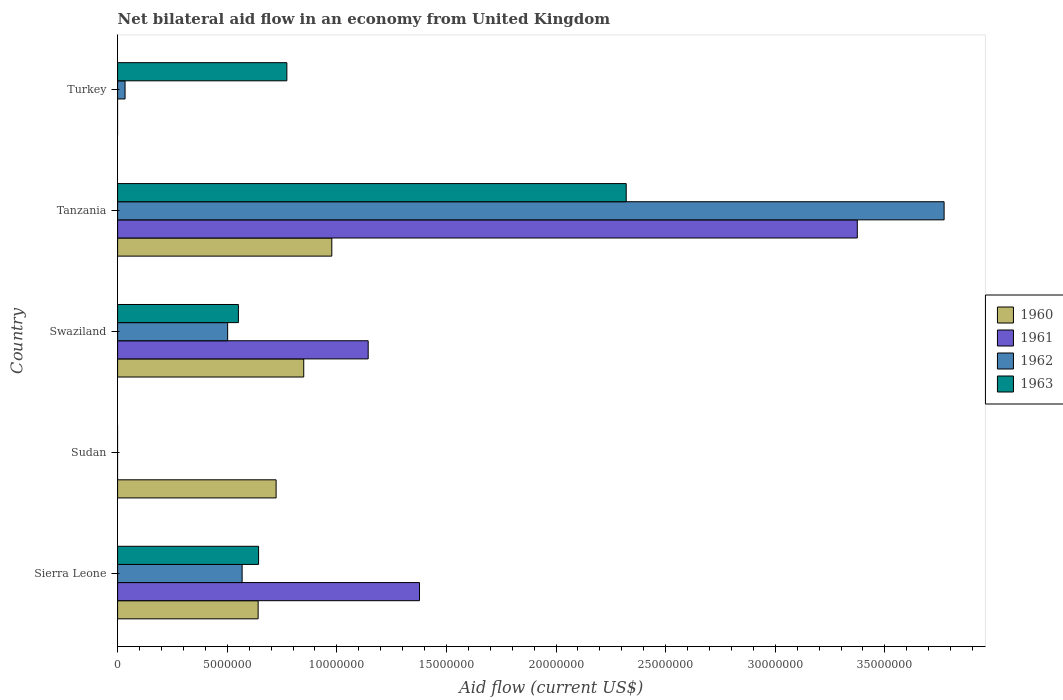Are the number of bars on each tick of the Y-axis equal?
Keep it short and to the point. No. How many bars are there on the 4th tick from the top?
Provide a short and direct response. 1. What is the label of the 4th group of bars from the top?
Provide a succinct answer. Sudan. In how many cases, is the number of bars for a given country not equal to the number of legend labels?
Your response must be concise. 2. What is the net bilateral aid flow in 1962 in Sierra Leone?
Your answer should be very brief. 5.68e+06. Across all countries, what is the maximum net bilateral aid flow in 1962?
Your response must be concise. 3.77e+07. In which country was the net bilateral aid flow in 1960 maximum?
Your answer should be compact. Tanzania. What is the total net bilateral aid flow in 1963 in the graph?
Ensure brevity in your answer.  4.29e+07. What is the difference between the net bilateral aid flow in 1963 in Swaziland and that in Turkey?
Keep it short and to the point. -2.21e+06. What is the difference between the net bilateral aid flow in 1962 in Tanzania and the net bilateral aid flow in 1961 in Swaziland?
Your answer should be very brief. 2.63e+07. What is the average net bilateral aid flow in 1960 per country?
Your answer should be compact. 6.38e+06. What is the difference between the net bilateral aid flow in 1962 and net bilateral aid flow in 1963 in Tanzania?
Your answer should be compact. 1.45e+07. In how many countries, is the net bilateral aid flow in 1962 greater than 9000000 US$?
Your answer should be very brief. 1. What is the ratio of the net bilateral aid flow in 1963 in Sierra Leone to that in Swaziland?
Keep it short and to the point. 1.17. Is the net bilateral aid flow in 1963 in Swaziland less than that in Tanzania?
Provide a succinct answer. Yes. Is the difference between the net bilateral aid flow in 1962 in Swaziland and Tanzania greater than the difference between the net bilateral aid flow in 1963 in Swaziland and Tanzania?
Provide a short and direct response. No. What is the difference between the highest and the second highest net bilateral aid flow in 1960?
Your answer should be compact. 1.28e+06. What is the difference between the highest and the lowest net bilateral aid flow in 1962?
Your response must be concise. 3.77e+07. In how many countries, is the net bilateral aid flow in 1960 greater than the average net bilateral aid flow in 1960 taken over all countries?
Offer a terse response. 4. Is the sum of the net bilateral aid flow in 1963 in Swaziland and Turkey greater than the maximum net bilateral aid flow in 1960 across all countries?
Your answer should be very brief. Yes. Is it the case that in every country, the sum of the net bilateral aid flow in 1960 and net bilateral aid flow in 1962 is greater than the sum of net bilateral aid flow in 1961 and net bilateral aid flow in 1963?
Your answer should be very brief. No. How many countries are there in the graph?
Your answer should be compact. 5. Where does the legend appear in the graph?
Your answer should be very brief. Center right. How many legend labels are there?
Offer a very short reply. 4. What is the title of the graph?
Your answer should be compact. Net bilateral aid flow in an economy from United Kingdom. Does "1997" appear as one of the legend labels in the graph?
Offer a terse response. No. What is the Aid flow (current US$) of 1960 in Sierra Leone?
Provide a succinct answer. 6.41e+06. What is the Aid flow (current US$) of 1961 in Sierra Leone?
Keep it short and to the point. 1.38e+07. What is the Aid flow (current US$) of 1962 in Sierra Leone?
Your answer should be very brief. 5.68e+06. What is the Aid flow (current US$) of 1963 in Sierra Leone?
Offer a very short reply. 6.43e+06. What is the Aid flow (current US$) in 1960 in Sudan?
Provide a short and direct response. 7.23e+06. What is the Aid flow (current US$) of 1963 in Sudan?
Your answer should be compact. 0. What is the Aid flow (current US$) in 1960 in Swaziland?
Give a very brief answer. 8.49e+06. What is the Aid flow (current US$) in 1961 in Swaziland?
Your answer should be very brief. 1.14e+07. What is the Aid flow (current US$) of 1962 in Swaziland?
Ensure brevity in your answer.  5.02e+06. What is the Aid flow (current US$) in 1963 in Swaziland?
Provide a short and direct response. 5.51e+06. What is the Aid flow (current US$) in 1960 in Tanzania?
Offer a very short reply. 9.77e+06. What is the Aid flow (current US$) in 1961 in Tanzania?
Your answer should be very brief. 3.37e+07. What is the Aid flow (current US$) of 1962 in Tanzania?
Offer a very short reply. 3.77e+07. What is the Aid flow (current US$) of 1963 in Tanzania?
Your answer should be very brief. 2.32e+07. What is the Aid flow (current US$) in 1960 in Turkey?
Provide a short and direct response. 0. What is the Aid flow (current US$) in 1961 in Turkey?
Ensure brevity in your answer.  0. What is the Aid flow (current US$) in 1963 in Turkey?
Ensure brevity in your answer.  7.72e+06. Across all countries, what is the maximum Aid flow (current US$) in 1960?
Provide a short and direct response. 9.77e+06. Across all countries, what is the maximum Aid flow (current US$) in 1961?
Keep it short and to the point. 3.37e+07. Across all countries, what is the maximum Aid flow (current US$) in 1962?
Make the answer very short. 3.77e+07. Across all countries, what is the maximum Aid flow (current US$) in 1963?
Your response must be concise. 2.32e+07. What is the total Aid flow (current US$) of 1960 in the graph?
Make the answer very short. 3.19e+07. What is the total Aid flow (current US$) of 1961 in the graph?
Your response must be concise. 5.89e+07. What is the total Aid flow (current US$) in 1962 in the graph?
Provide a succinct answer. 4.87e+07. What is the total Aid flow (current US$) in 1963 in the graph?
Keep it short and to the point. 4.29e+07. What is the difference between the Aid flow (current US$) in 1960 in Sierra Leone and that in Sudan?
Offer a terse response. -8.20e+05. What is the difference between the Aid flow (current US$) of 1960 in Sierra Leone and that in Swaziland?
Your response must be concise. -2.08e+06. What is the difference between the Aid flow (current US$) in 1961 in Sierra Leone and that in Swaziland?
Give a very brief answer. 2.34e+06. What is the difference between the Aid flow (current US$) of 1963 in Sierra Leone and that in Swaziland?
Keep it short and to the point. 9.20e+05. What is the difference between the Aid flow (current US$) in 1960 in Sierra Leone and that in Tanzania?
Your answer should be compact. -3.36e+06. What is the difference between the Aid flow (current US$) in 1961 in Sierra Leone and that in Tanzania?
Offer a very short reply. -2.00e+07. What is the difference between the Aid flow (current US$) in 1962 in Sierra Leone and that in Tanzania?
Keep it short and to the point. -3.20e+07. What is the difference between the Aid flow (current US$) in 1963 in Sierra Leone and that in Tanzania?
Ensure brevity in your answer.  -1.68e+07. What is the difference between the Aid flow (current US$) of 1962 in Sierra Leone and that in Turkey?
Your answer should be very brief. 5.34e+06. What is the difference between the Aid flow (current US$) in 1963 in Sierra Leone and that in Turkey?
Keep it short and to the point. -1.29e+06. What is the difference between the Aid flow (current US$) of 1960 in Sudan and that in Swaziland?
Offer a very short reply. -1.26e+06. What is the difference between the Aid flow (current US$) in 1960 in Sudan and that in Tanzania?
Your response must be concise. -2.54e+06. What is the difference between the Aid flow (current US$) in 1960 in Swaziland and that in Tanzania?
Provide a succinct answer. -1.28e+06. What is the difference between the Aid flow (current US$) of 1961 in Swaziland and that in Tanzania?
Keep it short and to the point. -2.23e+07. What is the difference between the Aid flow (current US$) of 1962 in Swaziland and that in Tanzania?
Provide a succinct answer. -3.27e+07. What is the difference between the Aid flow (current US$) in 1963 in Swaziland and that in Tanzania?
Offer a terse response. -1.77e+07. What is the difference between the Aid flow (current US$) of 1962 in Swaziland and that in Turkey?
Your answer should be compact. 4.68e+06. What is the difference between the Aid flow (current US$) of 1963 in Swaziland and that in Turkey?
Provide a succinct answer. -2.21e+06. What is the difference between the Aid flow (current US$) in 1962 in Tanzania and that in Turkey?
Offer a terse response. 3.74e+07. What is the difference between the Aid flow (current US$) of 1963 in Tanzania and that in Turkey?
Give a very brief answer. 1.55e+07. What is the difference between the Aid flow (current US$) of 1960 in Sierra Leone and the Aid flow (current US$) of 1961 in Swaziland?
Keep it short and to the point. -5.02e+06. What is the difference between the Aid flow (current US$) of 1960 in Sierra Leone and the Aid flow (current US$) of 1962 in Swaziland?
Your answer should be very brief. 1.39e+06. What is the difference between the Aid flow (current US$) in 1961 in Sierra Leone and the Aid flow (current US$) in 1962 in Swaziland?
Give a very brief answer. 8.75e+06. What is the difference between the Aid flow (current US$) in 1961 in Sierra Leone and the Aid flow (current US$) in 1963 in Swaziland?
Provide a succinct answer. 8.26e+06. What is the difference between the Aid flow (current US$) of 1960 in Sierra Leone and the Aid flow (current US$) of 1961 in Tanzania?
Provide a short and direct response. -2.73e+07. What is the difference between the Aid flow (current US$) of 1960 in Sierra Leone and the Aid flow (current US$) of 1962 in Tanzania?
Keep it short and to the point. -3.13e+07. What is the difference between the Aid flow (current US$) in 1960 in Sierra Leone and the Aid flow (current US$) in 1963 in Tanzania?
Offer a very short reply. -1.68e+07. What is the difference between the Aid flow (current US$) in 1961 in Sierra Leone and the Aid flow (current US$) in 1962 in Tanzania?
Offer a terse response. -2.39e+07. What is the difference between the Aid flow (current US$) in 1961 in Sierra Leone and the Aid flow (current US$) in 1963 in Tanzania?
Your answer should be compact. -9.43e+06. What is the difference between the Aid flow (current US$) in 1962 in Sierra Leone and the Aid flow (current US$) in 1963 in Tanzania?
Your answer should be compact. -1.75e+07. What is the difference between the Aid flow (current US$) of 1960 in Sierra Leone and the Aid flow (current US$) of 1962 in Turkey?
Keep it short and to the point. 6.07e+06. What is the difference between the Aid flow (current US$) of 1960 in Sierra Leone and the Aid flow (current US$) of 1963 in Turkey?
Provide a succinct answer. -1.31e+06. What is the difference between the Aid flow (current US$) in 1961 in Sierra Leone and the Aid flow (current US$) in 1962 in Turkey?
Give a very brief answer. 1.34e+07. What is the difference between the Aid flow (current US$) in 1961 in Sierra Leone and the Aid flow (current US$) in 1963 in Turkey?
Provide a short and direct response. 6.05e+06. What is the difference between the Aid flow (current US$) in 1962 in Sierra Leone and the Aid flow (current US$) in 1963 in Turkey?
Provide a succinct answer. -2.04e+06. What is the difference between the Aid flow (current US$) of 1960 in Sudan and the Aid flow (current US$) of 1961 in Swaziland?
Your response must be concise. -4.20e+06. What is the difference between the Aid flow (current US$) of 1960 in Sudan and the Aid flow (current US$) of 1962 in Swaziland?
Keep it short and to the point. 2.21e+06. What is the difference between the Aid flow (current US$) in 1960 in Sudan and the Aid flow (current US$) in 1963 in Swaziland?
Give a very brief answer. 1.72e+06. What is the difference between the Aid flow (current US$) in 1960 in Sudan and the Aid flow (current US$) in 1961 in Tanzania?
Ensure brevity in your answer.  -2.65e+07. What is the difference between the Aid flow (current US$) in 1960 in Sudan and the Aid flow (current US$) in 1962 in Tanzania?
Your response must be concise. -3.05e+07. What is the difference between the Aid flow (current US$) in 1960 in Sudan and the Aid flow (current US$) in 1963 in Tanzania?
Provide a succinct answer. -1.60e+07. What is the difference between the Aid flow (current US$) in 1960 in Sudan and the Aid flow (current US$) in 1962 in Turkey?
Provide a succinct answer. 6.89e+06. What is the difference between the Aid flow (current US$) in 1960 in Sudan and the Aid flow (current US$) in 1963 in Turkey?
Make the answer very short. -4.90e+05. What is the difference between the Aid flow (current US$) in 1960 in Swaziland and the Aid flow (current US$) in 1961 in Tanzania?
Your answer should be compact. -2.52e+07. What is the difference between the Aid flow (current US$) in 1960 in Swaziland and the Aid flow (current US$) in 1962 in Tanzania?
Offer a very short reply. -2.92e+07. What is the difference between the Aid flow (current US$) in 1960 in Swaziland and the Aid flow (current US$) in 1963 in Tanzania?
Your answer should be compact. -1.47e+07. What is the difference between the Aid flow (current US$) of 1961 in Swaziland and the Aid flow (current US$) of 1962 in Tanzania?
Provide a succinct answer. -2.63e+07. What is the difference between the Aid flow (current US$) in 1961 in Swaziland and the Aid flow (current US$) in 1963 in Tanzania?
Offer a very short reply. -1.18e+07. What is the difference between the Aid flow (current US$) of 1962 in Swaziland and the Aid flow (current US$) of 1963 in Tanzania?
Keep it short and to the point. -1.82e+07. What is the difference between the Aid flow (current US$) of 1960 in Swaziland and the Aid flow (current US$) of 1962 in Turkey?
Make the answer very short. 8.15e+06. What is the difference between the Aid flow (current US$) of 1960 in Swaziland and the Aid flow (current US$) of 1963 in Turkey?
Your answer should be compact. 7.70e+05. What is the difference between the Aid flow (current US$) of 1961 in Swaziland and the Aid flow (current US$) of 1962 in Turkey?
Provide a succinct answer. 1.11e+07. What is the difference between the Aid flow (current US$) in 1961 in Swaziland and the Aid flow (current US$) in 1963 in Turkey?
Offer a very short reply. 3.71e+06. What is the difference between the Aid flow (current US$) in 1962 in Swaziland and the Aid flow (current US$) in 1963 in Turkey?
Give a very brief answer. -2.70e+06. What is the difference between the Aid flow (current US$) of 1960 in Tanzania and the Aid flow (current US$) of 1962 in Turkey?
Your response must be concise. 9.43e+06. What is the difference between the Aid flow (current US$) of 1960 in Tanzania and the Aid flow (current US$) of 1963 in Turkey?
Provide a short and direct response. 2.05e+06. What is the difference between the Aid flow (current US$) of 1961 in Tanzania and the Aid flow (current US$) of 1962 in Turkey?
Offer a terse response. 3.34e+07. What is the difference between the Aid flow (current US$) of 1961 in Tanzania and the Aid flow (current US$) of 1963 in Turkey?
Your answer should be compact. 2.60e+07. What is the difference between the Aid flow (current US$) in 1962 in Tanzania and the Aid flow (current US$) in 1963 in Turkey?
Your answer should be very brief. 3.00e+07. What is the average Aid flow (current US$) in 1960 per country?
Your response must be concise. 6.38e+06. What is the average Aid flow (current US$) of 1961 per country?
Offer a very short reply. 1.18e+07. What is the average Aid flow (current US$) in 1962 per country?
Offer a very short reply. 9.75e+06. What is the average Aid flow (current US$) of 1963 per country?
Offer a terse response. 8.57e+06. What is the difference between the Aid flow (current US$) of 1960 and Aid flow (current US$) of 1961 in Sierra Leone?
Keep it short and to the point. -7.36e+06. What is the difference between the Aid flow (current US$) in 1960 and Aid flow (current US$) in 1962 in Sierra Leone?
Provide a short and direct response. 7.30e+05. What is the difference between the Aid flow (current US$) of 1961 and Aid flow (current US$) of 1962 in Sierra Leone?
Your response must be concise. 8.09e+06. What is the difference between the Aid flow (current US$) of 1961 and Aid flow (current US$) of 1963 in Sierra Leone?
Offer a terse response. 7.34e+06. What is the difference between the Aid flow (current US$) in 1962 and Aid flow (current US$) in 1963 in Sierra Leone?
Provide a succinct answer. -7.50e+05. What is the difference between the Aid flow (current US$) of 1960 and Aid flow (current US$) of 1961 in Swaziland?
Provide a succinct answer. -2.94e+06. What is the difference between the Aid flow (current US$) in 1960 and Aid flow (current US$) in 1962 in Swaziland?
Offer a terse response. 3.47e+06. What is the difference between the Aid flow (current US$) in 1960 and Aid flow (current US$) in 1963 in Swaziland?
Provide a succinct answer. 2.98e+06. What is the difference between the Aid flow (current US$) of 1961 and Aid flow (current US$) of 1962 in Swaziland?
Your answer should be very brief. 6.41e+06. What is the difference between the Aid flow (current US$) in 1961 and Aid flow (current US$) in 1963 in Swaziland?
Provide a succinct answer. 5.92e+06. What is the difference between the Aid flow (current US$) in 1962 and Aid flow (current US$) in 1963 in Swaziland?
Give a very brief answer. -4.90e+05. What is the difference between the Aid flow (current US$) in 1960 and Aid flow (current US$) in 1961 in Tanzania?
Offer a terse response. -2.40e+07. What is the difference between the Aid flow (current US$) of 1960 and Aid flow (current US$) of 1962 in Tanzania?
Offer a very short reply. -2.79e+07. What is the difference between the Aid flow (current US$) of 1960 and Aid flow (current US$) of 1963 in Tanzania?
Your response must be concise. -1.34e+07. What is the difference between the Aid flow (current US$) in 1961 and Aid flow (current US$) in 1962 in Tanzania?
Your answer should be compact. -3.96e+06. What is the difference between the Aid flow (current US$) of 1961 and Aid flow (current US$) of 1963 in Tanzania?
Your response must be concise. 1.05e+07. What is the difference between the Aid flow (current US$) in 1962 and Aid flow (current US$) in 1963 in Tanzania?
Your answer should be compact. 1.45e+07. What is the difference between the Aid flow (current US$) in 1962 and Aid flow (current US$) in 1963 in Turkey?
Give a very brief answer. -7.38e+06. What is the ratio of the Aid flow (current US$) in 1960 in Sierra Leone to that in Sudan?
Provide a succinct answer. 0.89. What is the ratio of the Aid flow (current US$) of 1960 in Sierra Leone to that in Swaziland?
Ensure brevity in your answer.  0.76. What is the ratio of the Aid flow (current US$) of 1961 in Sierra Leone to that in Swaziland?
Your answer should be very brief. 1.2. What is the ratio of the Aid flow (current US$) in 1962 in Sierra Leone to that in Swaziland?
Make the answer very short. 1.13. What is the ratio of the Aid flow (current US$) in 1963 in Sierra Leone to that in Swaziland?
Provide a short and direct response. 1.17. What is the ratio of the Aid flow (current US$) in 1960 in Sierra Leone to that in Tanzania?
Ensure brevity in your answer.  0.66. What is the ratio of the Aid flow (current US$) in 1961 in Sierra Leone to that in Tanzania?
Ensure brevity in your answer.  0.41. What is the ratio of the Aid flow (current US$) in 1962 in Sierra Leone to that in Tanzania?
Your answer should be very brief. 0.15. What is the ratio of the Aid flow (current US$) of 1963 in Sierra Leone to that in Tanzania?
Keep it short and to the point. 0.28. What is the ratio of the Aid flow (current US$) of 1962 in Sierra Leone to that in Turkey?
Provide a short and direct response. 16.71. What is the ratio of the Aid flow (current US$) of 1963 in Sierra Leone to that in Turkey?
Offer a very short reply. 0.83. What is the ratio of the Aid flow (current US$) of 1960 in Sudan to that in Swaziland?
Give a very brief answer. 0.85. What is the ratio of the Aid flow (current US$) of 1960 in Sudan to that in Tanzania?
Make the answer very short. 0.74. What is the ratio of the Aid flow (current US$) in 1960 in Swaziland to that in Tanzania?
Provide a short and direct response. 0.87. What is the ratio of the Aid flow (current US$) of 1961 in Swaziland to that in Tanzania?
Provide a short and direct response. 0.34. What is the ratio of the Aid flow (current US$) of 1962 in Swaziland to that in Tanzania?
Your answer should be very brief. 0.13. What is the ratio of the Aid flow (current US$) of 1963 in Swaziland to that in Tanzania?
Provide a succinct answer. 0.24. What is the ratio of the Aid flow (current US$) of 1962 in Swaziland to that in Turkey?
Keep it short and to the point. 14.76. What is the ratio of the Aid flow (current US$) in 1963 in Swaziland to that in Turkey?
Your answer should be very brief. 0.71. What is the ratio of the Aid flow (current US$) in 1962 in Tanzania to that in Turkey?
Give a very brief answer. 110.88. What is the ratio of the Aid flow (current US$) in 1963 in Tanzania to that in Turkey?
Give a very brief answer. 3.01. What is the difference between the highest and the second highest Aid flow (current US$) of 1960?
Offer a very short reply. 1.28e+06. What is the difference between the highest and the second highest Aid flow (current US$) of 1961?
Provide a succinct answer. 2.00e+07. What is the difference between the highest and the second highest Aid flow (current US$) in 1962?
Give a very brief answer. 3.20e+07. What is the difference between the highest and the second highest Aid flow (current US$) of 1963?
Offer a terse response. 1.55e+07. What is the difference between the highest and the lowest Aid flow (current US$) in 1960?
Keep it short and to the point. 9.77e+06. What is the difference between the highest and the lowest Aid flow (current US$) in 1961?
Your answer should be very brief. 3.37e+07. What is the difference between the highest and the lowest Aid flow (current US$) of 1962?
Provide a succinct answer. 3.77e+07. What is the difference between the highest and the lowest Aid flow (current US$) of 1963?
Your response must be concise. 2.32e+07. 